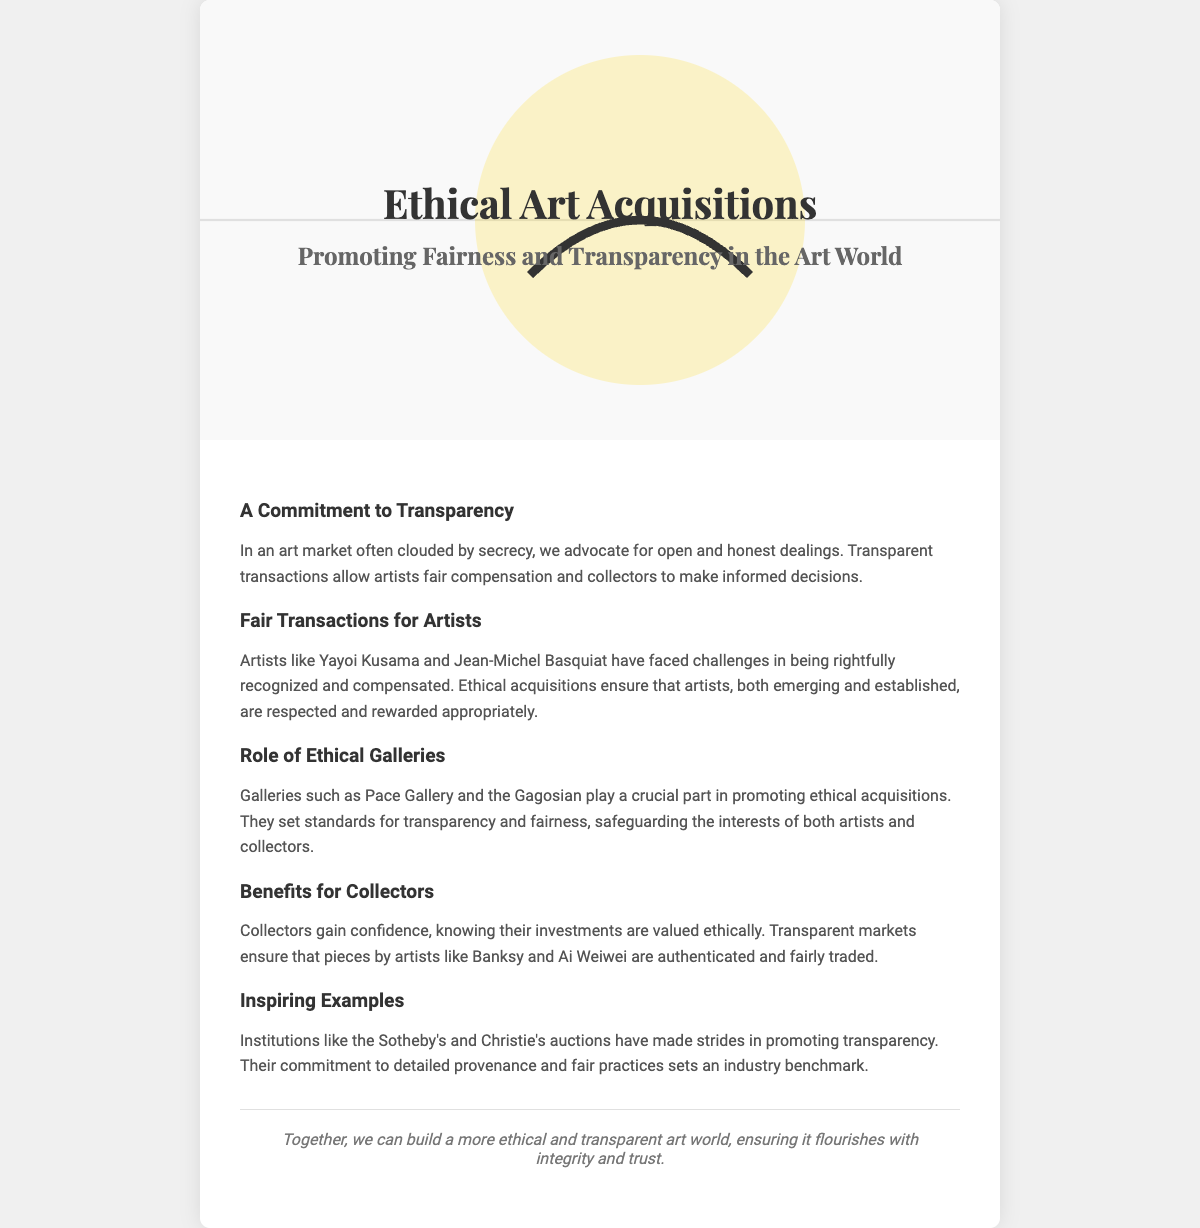What is the main theme of the greeting card? The main theme is promoting ethical art acquisitions through fairness and transparency in transactions.
Answer: Ethical Art Acquisitions Who is mentioned as facing challenges in recognition and compensation? The card mentions artists who have faced challenges, like Kusama and Basquiat.
Answer: Yayoi Kusama and Jean-Michel Basquiat What role do galleries like Pace Gallery play? The card states that these galleries set standards for transparency and fairness in the art market.
Answer: Ethical acquisitions What is a benefit for collectors mentioned in the card? The card mentions that collectors gain confidence knowing their investments are valued ethically.
Answer: Confidence Which institutions are noted for making strides in promoting transparency? The card highlights Sotheby's and Christie's for their commitment to fair practices and detailed provenance.
Answer: Sotheby's and Christie's 